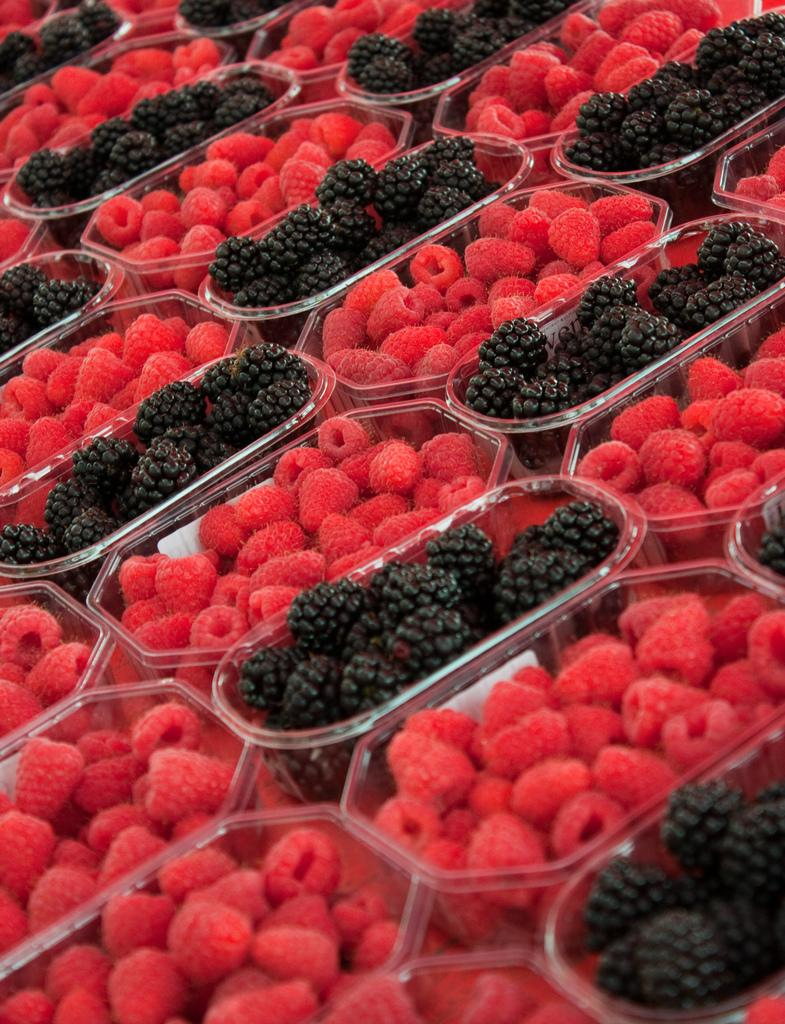What objects are present in the image? There are boxes in the image. What are the boxes containing? The boxes contain fruits. Can you describe the appearance of the fruits? The fruits are in red and black colors. What type of patch is sewn onto the foot of the fruit in the image? There is no patch or foot mentioned in the image; it features boxes containing fruits in red and black colors. 